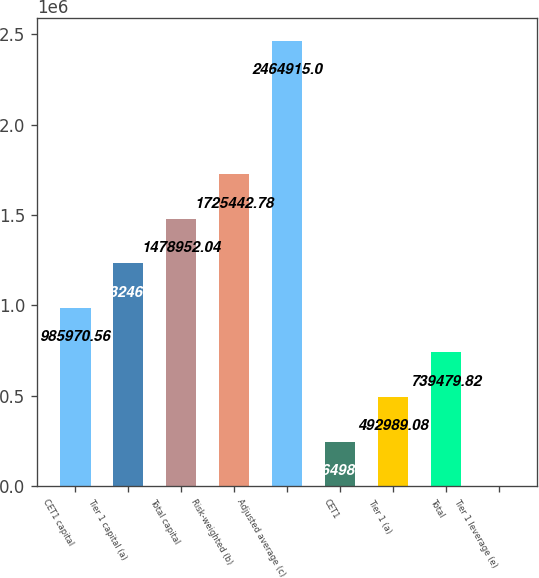Convert chart to OTSL. <chart><loc_0><loc_0><loc_500><loc_500><bar_chart><fcel>CET1 capital<fcel>Tier 1 capital (a)<fcel>Total capital<fcel>Risk-weighted (b)<fcel>Adjusted average (c)<fcel>CET1<fcel>Tier 1 (a)<fcel>Total<fcel>Tier 1 leverage (e)<nl><fcel>985971<fcel>1.23246e+06<fcel>1.47895e+06<fcel>1.72544e+06<fcel>2.46492e+06<fcel>246498<fcel>492989<fcel>739480<fcel>7.6<nl></chart> 